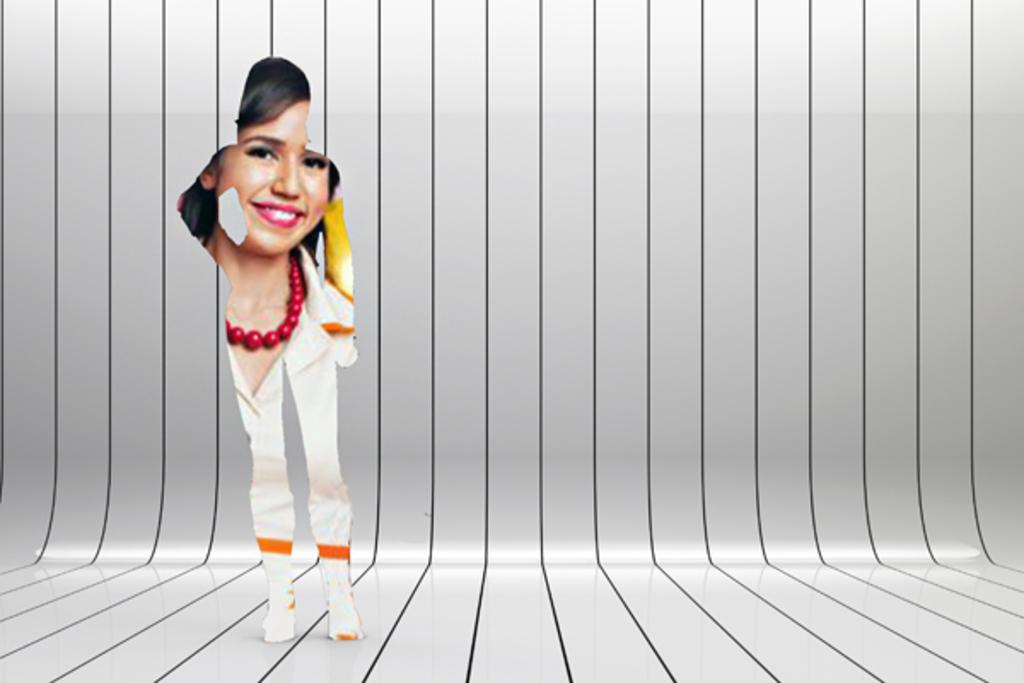What can be observed about the image's appearance? The image is edited. Who is present in the image? There is a woman in the image. What type of cake can be seen on the road in the image? There is no cake or road present in the image; it only features a woman. How does the woman's digestion appear to be affected by the image's editing? There is no indication of the woman's digestion in the image, and the editing does not affect her physical state. 